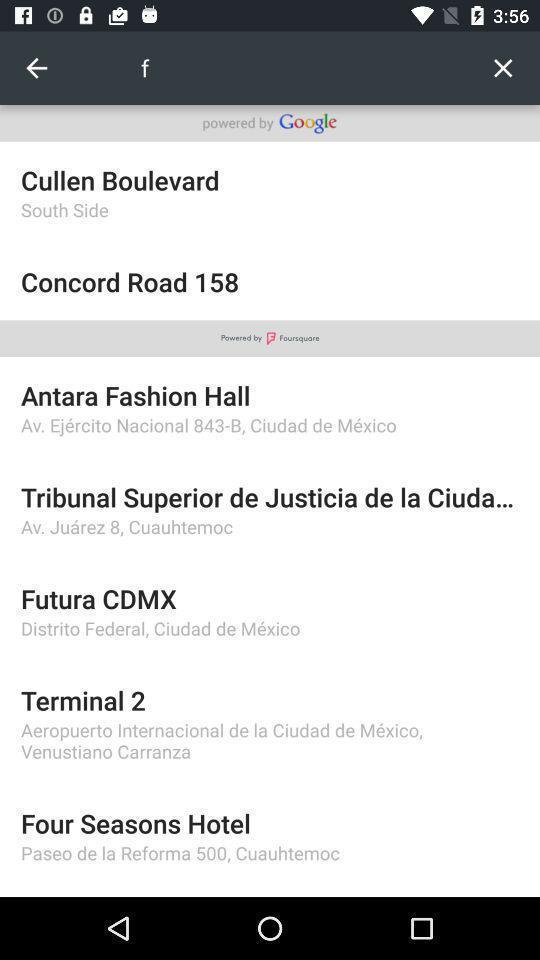Tell me what you see in this picture. Page displays search bar to search in app. 